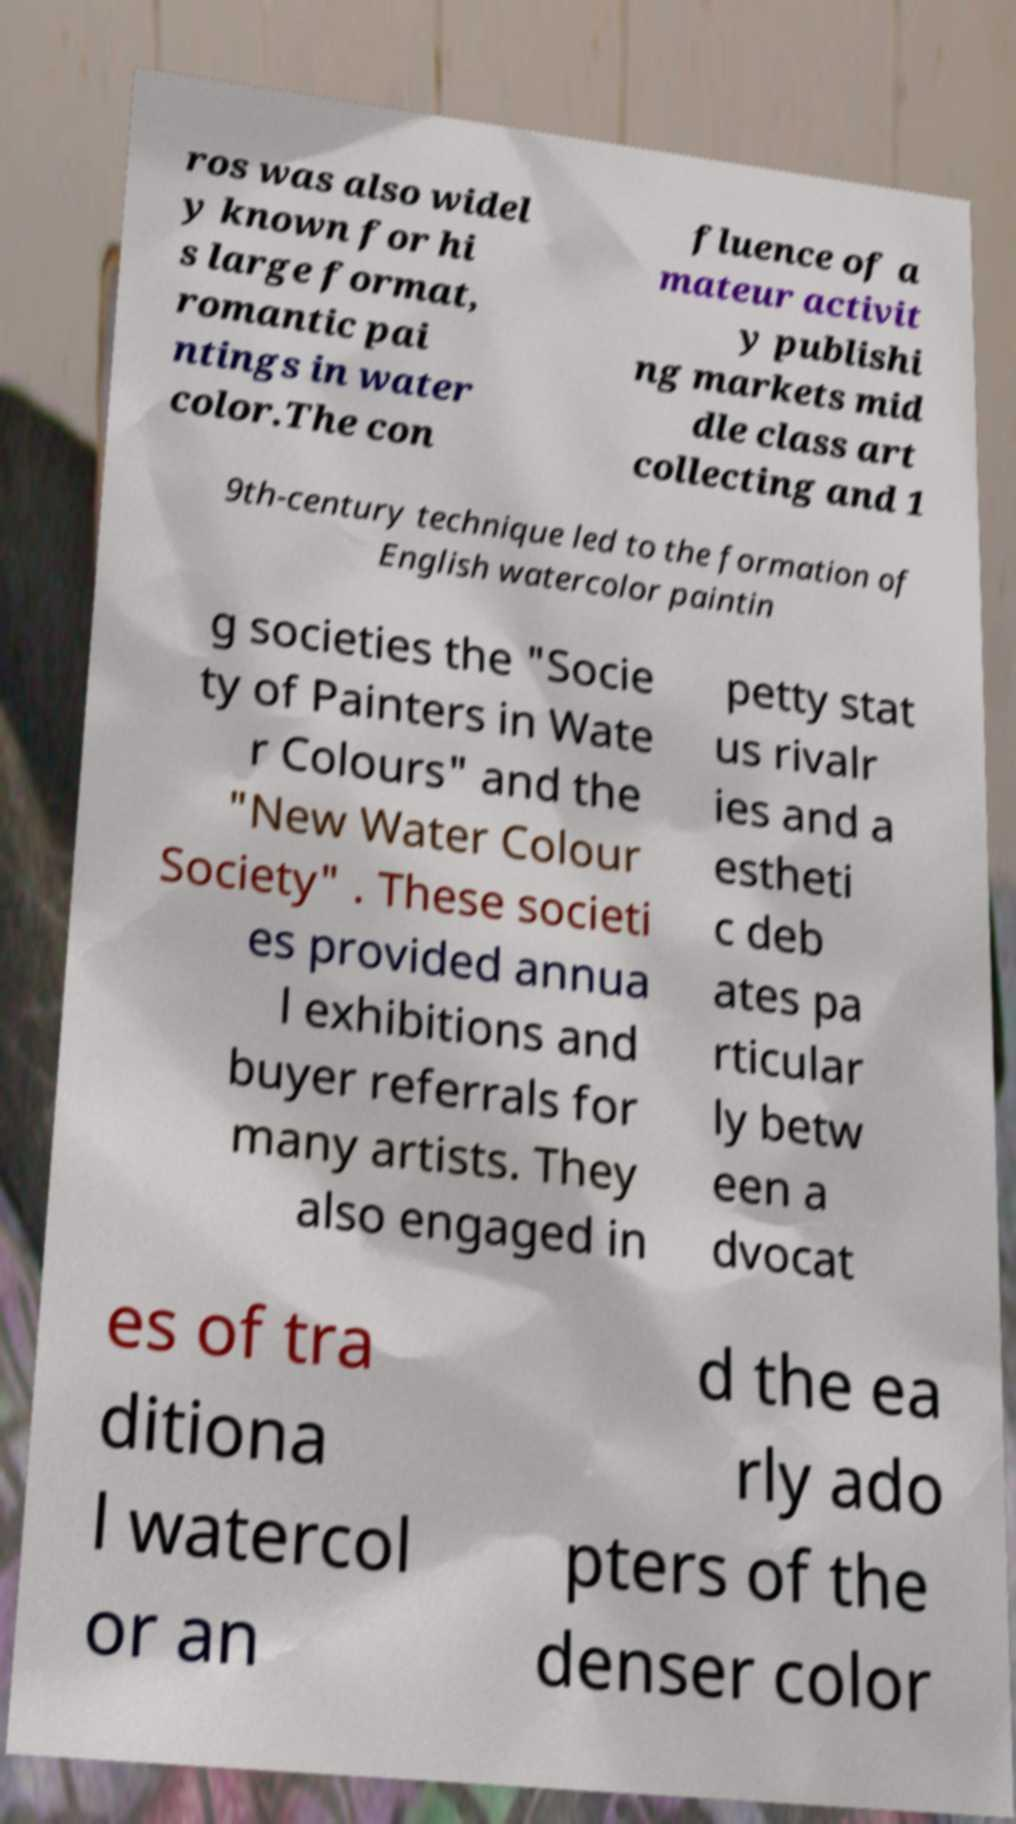Please read and relay the text visible in this image. What does it say? ros was also widel y known for hi s large format, romantic pai ntings in water color.The con fluence of a mateur activit y publishi ng markets mid dle class art collecting and 1 9th-century technique led to the formation of English watercolor paintin g societies the "Socie ty of Painters in Wate r Colours" and the "New Water Colour Society" . These societi es provided annua l exhibitions and buyer referrals for many artists. They also engaged in petty stat us rivalr ies and a estheti c deb ates pa rticular ly betw een a dvocat es of tra ditiona l watercol or an d the ea rly ado pters of the denser color 